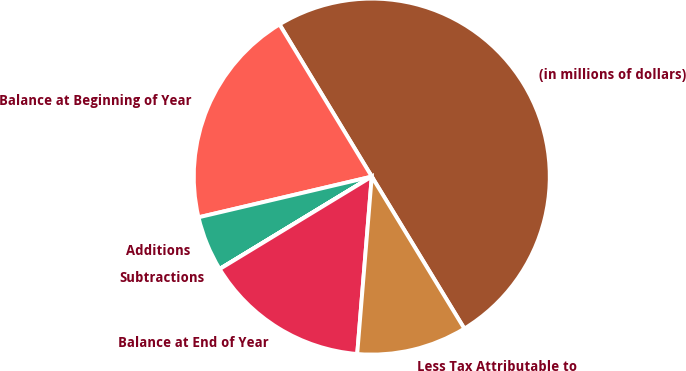Convert chart. <chart><loc_0><loc_0><loc_500><loc_500><pie_chart><fcel>(in millions of dollars)<fcel>Balance at Beginning of Year<fcel>Additions<fcel>Subtractions<fcel>Balance at End of Year<fcel>Less Tax Attributable to<nl><fcel>49.97%<fcel>20.0%<fcel>5.01%<fcel>0.01%<fcel>15.0%<fcel>10.01%<nl></chart> 